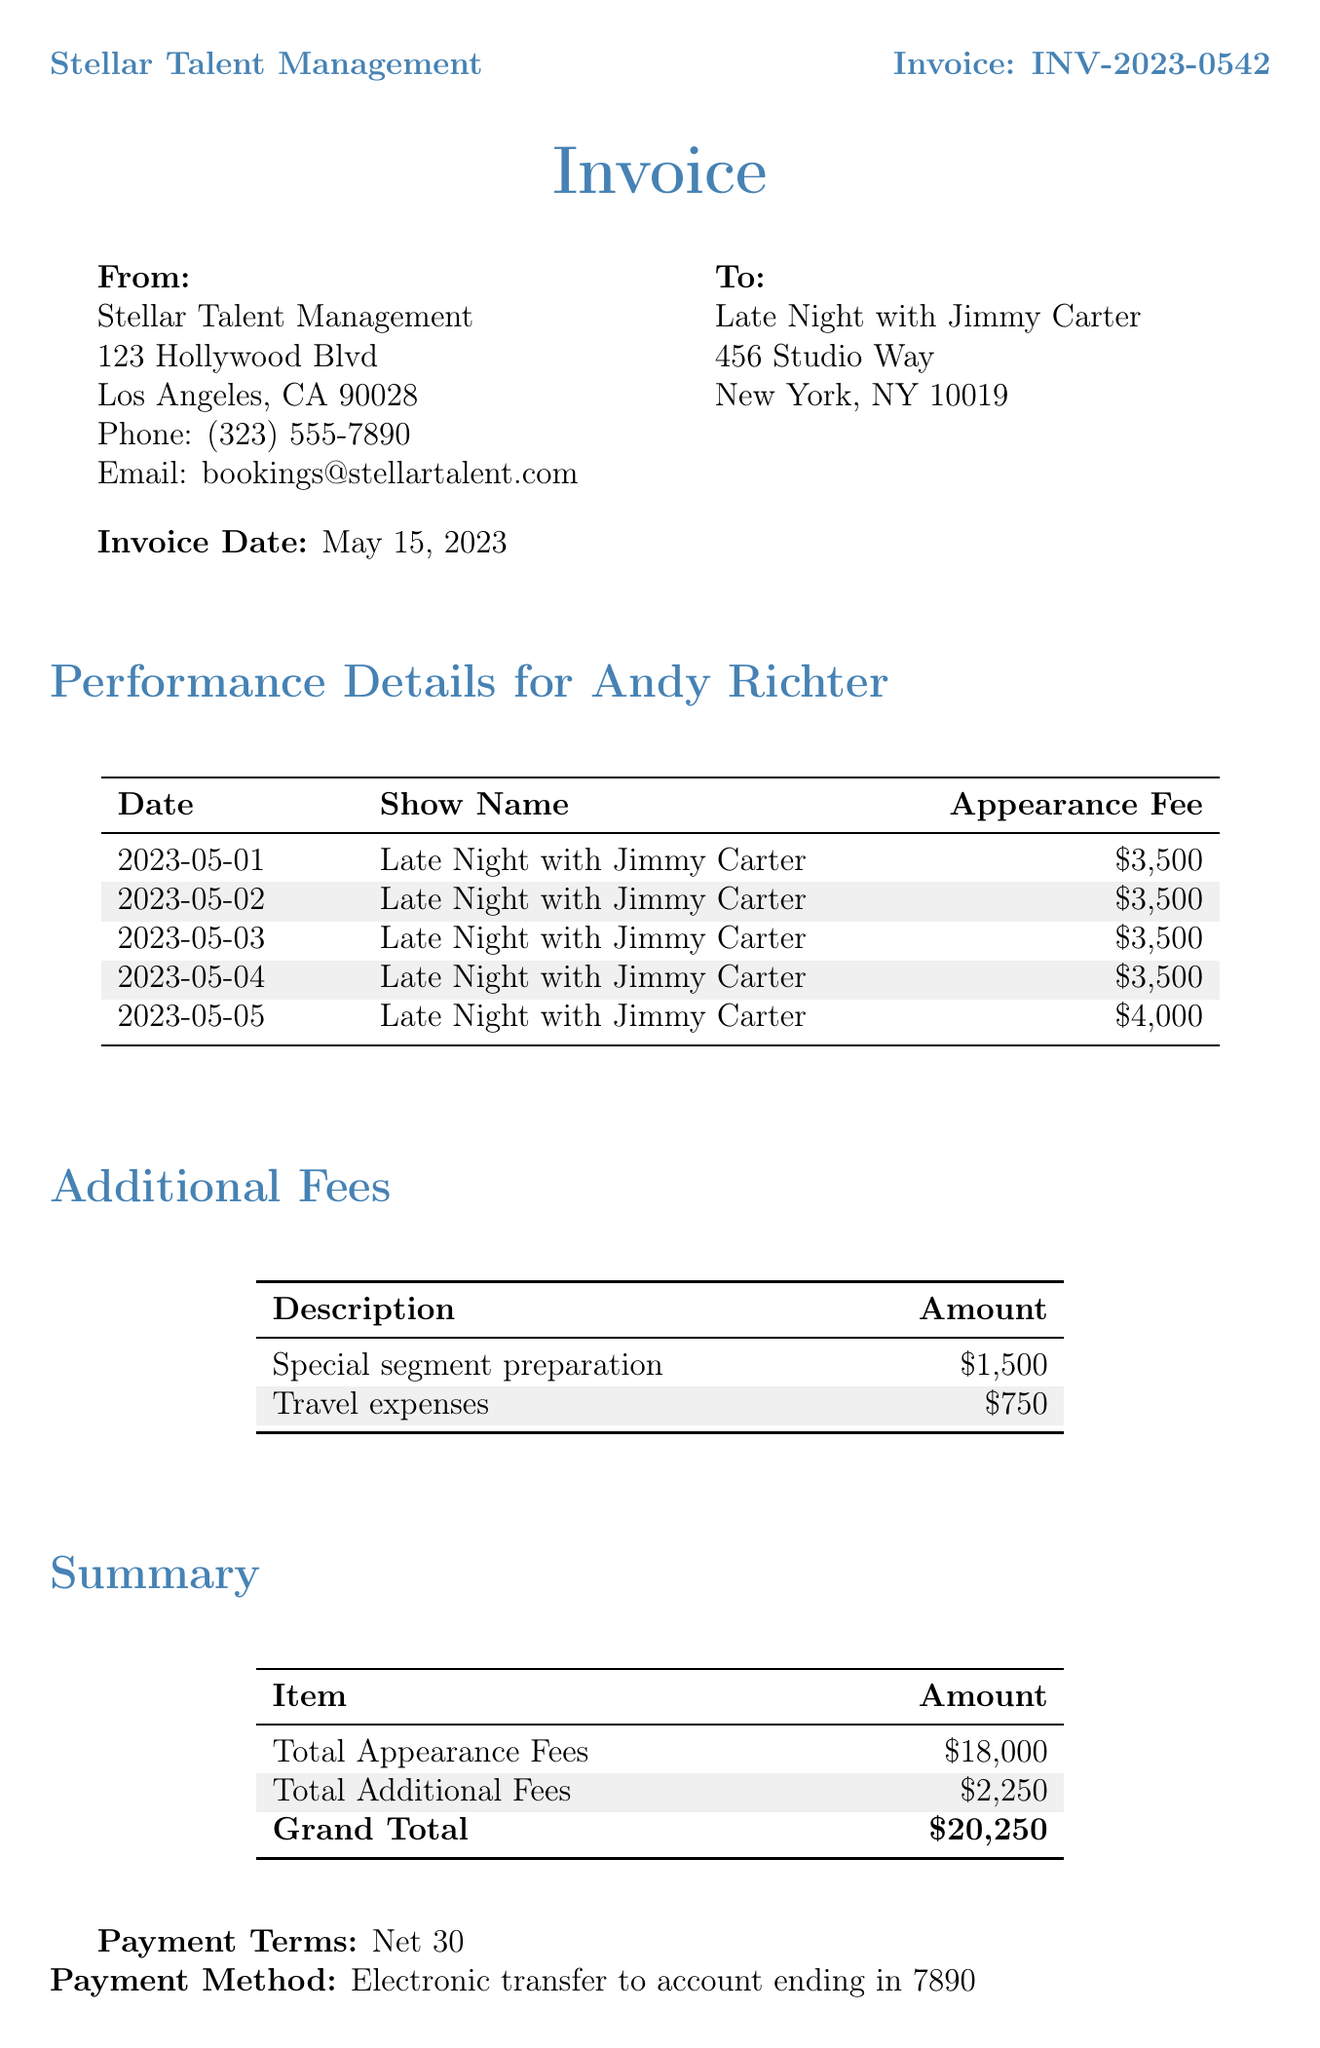What is the agency name? The agency name is displayed prominently at the top of the document.
Answer: Stellar Talent Management What is the total appearance fee? The total appearance fee is calculated and listed in the summary section of the invoice.
Answer: $18,000 How many performance dates are listed? The document includes a table that shows each performance date, which can be counted directly.
Answer: 5 What is the total for additional fees? The total for additional fees is provided in the summary, which combines the amounts from the additional fees section.
Answer: $2,250 What is the invoice date? The invoice date is clearly stated in the document below the client name.
Answer: May 15, 2023 What payment terms are specified? The payment terms are typically outlined in the summary section, indicating when payment is due.
Answer: Net 30 Who is the sidekick mentioned in the document? The sidekick is named in the performance details section of the invoice.
Answer: Andy Richter What was the appearance fee for the performance on May 5, 2023? The appearance fee for this specific date is listed in the performance details table.
Answer: $4,000 